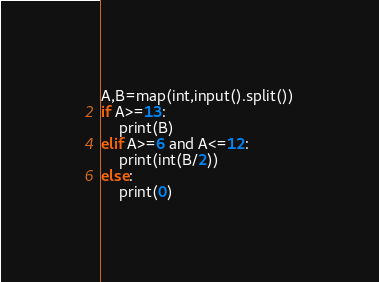<code> <loc_0><loc_0><loc_500><loc_500><_Python_>A,B=map(int,input().split())
if A>=13:
    print(B)
elif A>=6 and A<=12:
    print(int(B/2))
else:
    print(0)</code> 